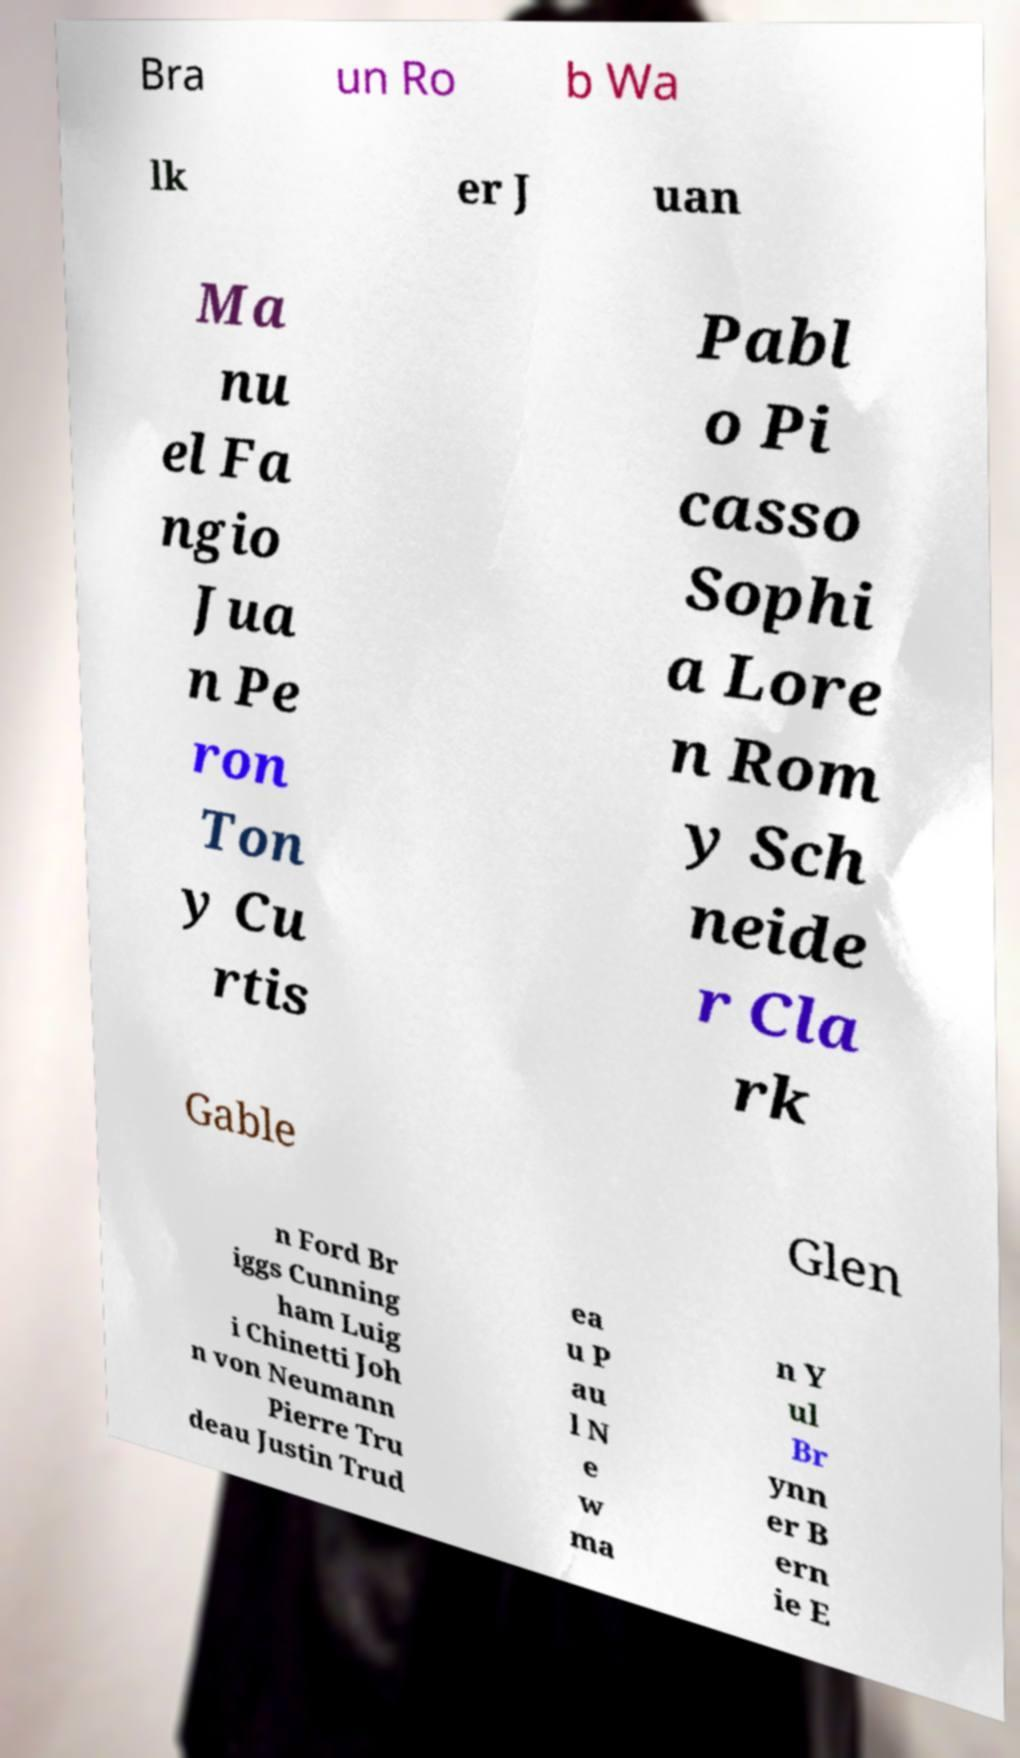Please read and relay the text visible in this image. What does it say? Bra un Ro b Wa lk er J uan Ma nu el Fa ngio Jua n Pe ron Ton y Cu rtis Pabl o Pi casso Sophi a Lore n Rom y Sch neide r Cla rk Gable Glen n Ford Br iggs Cunning ham Luig i Chinetti Joh n von Neumann Pierre Tru deau Justin Trud ea u P au l N e w ma n Y ul Br ynn er B ern ie E 